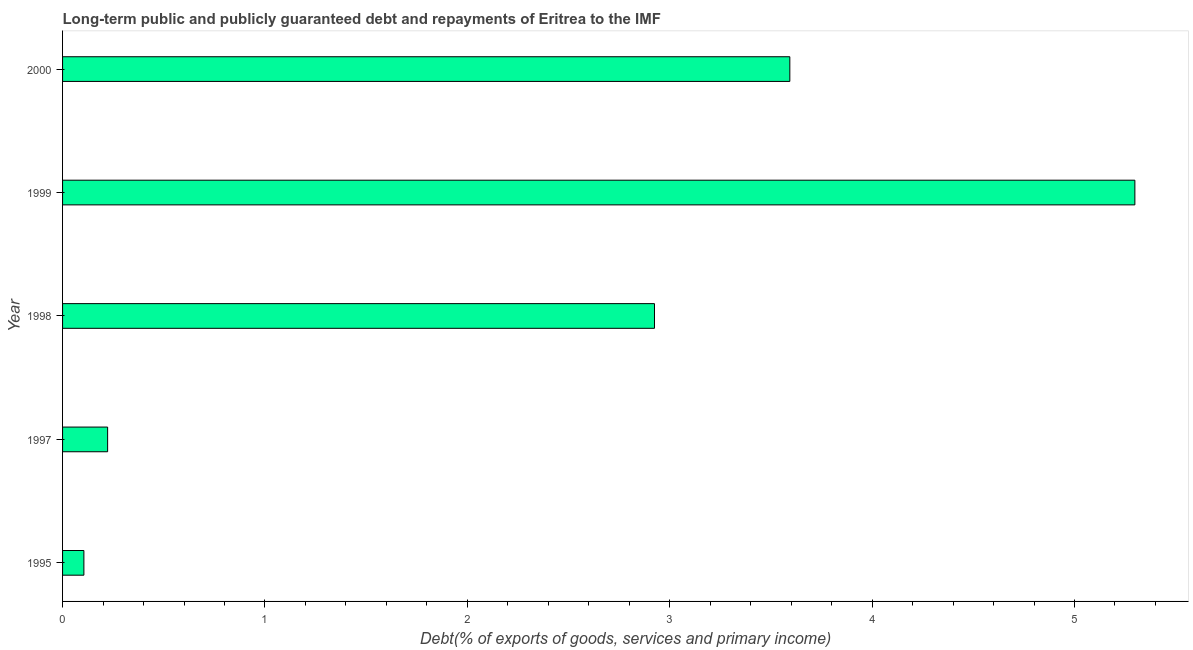Does the graph contain any zero values?
Offer a very short reply. No. Does the graph contain grids?
Provide a short and direct response. No. What is the title of the graph?
Give a very brief answer. Long-term public and publicly guaranteed debt and repayments of Eritrea to the IMF. What is the label or title of the X-axis?
Your answer should be very brief. Debt(% of exports of goods, services and primary income). What is the debt service in 2000?
Keep it short and to the point. 3.59. Across all years, what is the maximum debt service?
Keep it short and to the point. 5.3. Across all years, what is the minimum debt service?
Keep it short and to the point. 0.11. What is the sum of the debt service?
Offer a terse response. 12.14. What is the difference between the debt service in 1995 and 1998?
Provide a succinct answer. -2.82. What is the average debt service per year?
Provide a short and direct response. 2.43. What is the median debt service?
Offer a very short reply. 2.92. What is the ratio of the debt service in 1997 to that in 2000?
Your response must be concise. 0.06. Is the debt service in 1995 less than that in 1997?
Provide a succinct answer. Yes. What is the difference between the highest and the second highest debt service?
Provide a short and direct response. 1.71. What is the difference between the highest and the lowest debt service?
Ensure brevity in your answer.  5.19. In how many years, is the debt service greater than the average debt service taken over all years?
Give a very brief answer. 3. Are all the bars in the graph horizontal?
Your answer should be compact. Yes. What is the Debt(% of exports of goods, services and primary income) in 1995?
Your response must be concise. 0.11. What is the Debt(% of exports of goods, services and primary income) in 1997?
Make the answer very short. 0.22. What is the Debt(% of exports of goods, services and primary income) of 1998?
Provide a short and direct response. 2.92. What is the Debt(% of exports of goods, services and primary income) in 1999?
Your answer should be very brief. 5.3. What is the Debt(% of exports of goods, services and primary income) of 2000?
Provide a short and direct response. 3.59. What is the difference between the Debt(% of exports of goods, services and primary income) in 1995 and 1997?
Your answer should be compact. -0.12. What is the difference between the Debt(% of exports of goods, services and primary income) in 1995 and 1998?
Provide a short and direct response. -2.82. What is the difference between the Debt(% of exports of goods, services and primary income) in 1995 and 1999?
Your answer should be compact. -5.19. What is the difference between the Debt(% of exports of goods, services and primary income) in 1995 and 2000?
Keep it short and to the point. -3.49. What is the difference between the Debt(% of exports of goods, services and primary income) in 1997 and 1998?
Your response must be concise. -2.7. What is the difference between the Debt(% of exports of goods, services and primary income) in 1997 and 1999?
Provide a succinct answer. -5.08. What is the difference between the Debt(% of exports of goods, services and primary income) in 1997 and 2000?
Your answer should be very brief. -3.37. What is the difference between the Debt(% of exports of goods, services and primary income) in 1998 and 1999?
Your answer should be very brief. -2.37. What is the difference between the Debt(% of exports of goods, services and primary income) in 1998 and 2000?
Provide a succinct answer. -0.67. What is the difference between the Debt(% of exports of goods, services and primary income) in 1999 and 2000?
Offer a very short reply. 1.7. What is the ratio of the Debt(% of exports of goods, services and primary income) in 1995 to that in 1997?
Provide a short and direct response. 0.47. What is the ratio of the Debt(% of exports of goods, services and primary income) in 1995 to that in 1998?
Ensure brevity in your answer.  0.04. What is the ratio of the Debt(% of exports of goods, services and primary income) in 1995 to that in 1999?
Make the answer very short. 0.02. What is the ratio of the Debt(% of exports of goods, services and primary income) in 1995 to that in 2000?
Ensure brevity in your answer.  0.03. What is the ratio of the Debt(% of exports of goods, services and primary income) in 1997 to that in 1998?
Offer a terse response. 0.08. What is the ratio of the Debt(% of exports of goods, services and primary income) in 1997 to that in 1999?
Offer a terse response. 0.04. What is the ratio of the Debt(% of exports of goods, services and primary income) in 1997 to that in 2000?
Provide a short and direct response. 0.06. What is the ratio of the Debt(% of exports of goods, services and primary income) in 1998 to that in 1999?
Make the answer very short. 0.55. What is the ratio of the Debt(% of exports of goods, services and primary income) in 1998 to that in 2000?
Keep it short and to the point. 0.81. What is the ratio of the Debt(% of exports of goods, services and primary income) in 1999 to that in 2000?
Give a very brief answer. 1.47. 